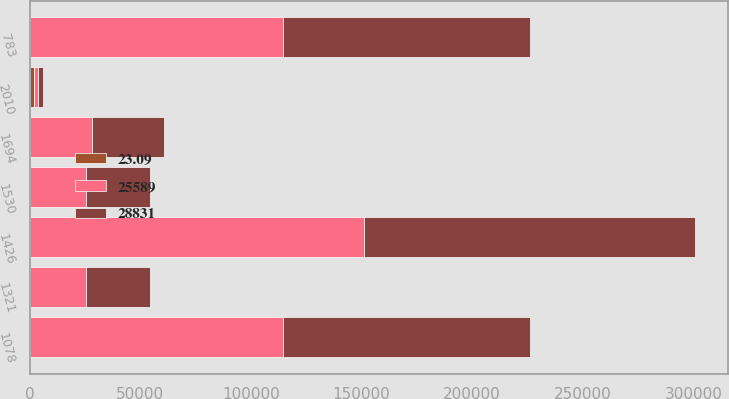Convert chart to OTSL. <chart><loc_0><loc_0><loc_500><loc_500><stacked_bar_chart><ecel><fcel>2010<fcel>1078<fcel>1530<fcel>1426<fcel>1694<fcel>783<fcel>1321<nl><fcel>25589<fcel>2010<fcel>114345<fcel>25589<fcel>151255<fcel>28343<fcel>114345<fcel>25589<nl><fcel>23.09<fcel>2009<fcel>10.3<fcel>15.21<fcel>13.76<fcel>17.01<fcel>7.38<fcel>23.09<nl><fcel>28831<fcel>2009<fcel>111916<fcel>28831<fcel>149528<fcel>32244<fcel>111916<fcel>28831<nl></chart> 